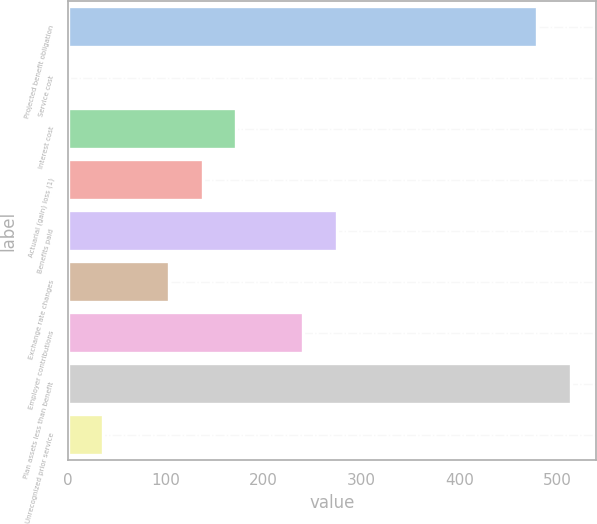<chart> <loc_0><loc_0><loc_500><loc_500><bar_chart><fcel>Projected benefit obligation<fcel>Service cost<fcel>Interest cost<fcel>Actuarial (gain) loss (1)<fcel>Benefits paid<fcel>Exchange rate changes<fcel>Employer contributions<fcel>Plan assets less than benefit<fcel>Unrecognized prior service<nl><fcel>479.8<fcel>1<fcel>172<fcel>137.8<fcel>274.6<fcel>103.6<fcel>240.4<fcel>514<fcel>35.2<nl></chart> 